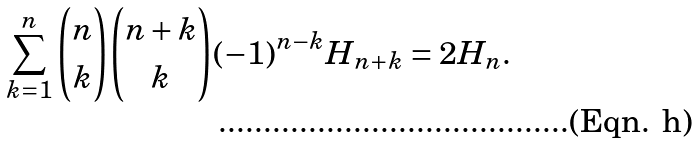<formula> <loc_0><loc_0><loc_500><loc_500>\sum _ { k = 1 } ^ { n } \binom { n } { k } \binom { n + k } k ( - 1 ) ^ { n - k } H _ { n + k } = 2 H _ { n } .</formula> 